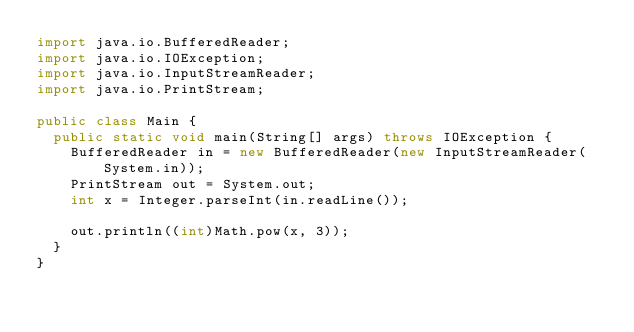<code> <loc_0><loc_0><loc_500><loc_500><_Java_>import java.io.BufferedReader;
import java.io.IOException;
import java.io.InputStreamReader;
import java.io.PrintStream;

public class Main {
	public static void main(String[] args) throws IOException {
		BufferedReader in = new BufferedReader(new InputStreamReader(System.in));
		PrintStream out = System.out;
		int x = Integer.parseInt(in.readLine());

		out.println((int)Math.pow(x, 3));
	}
}</code> 